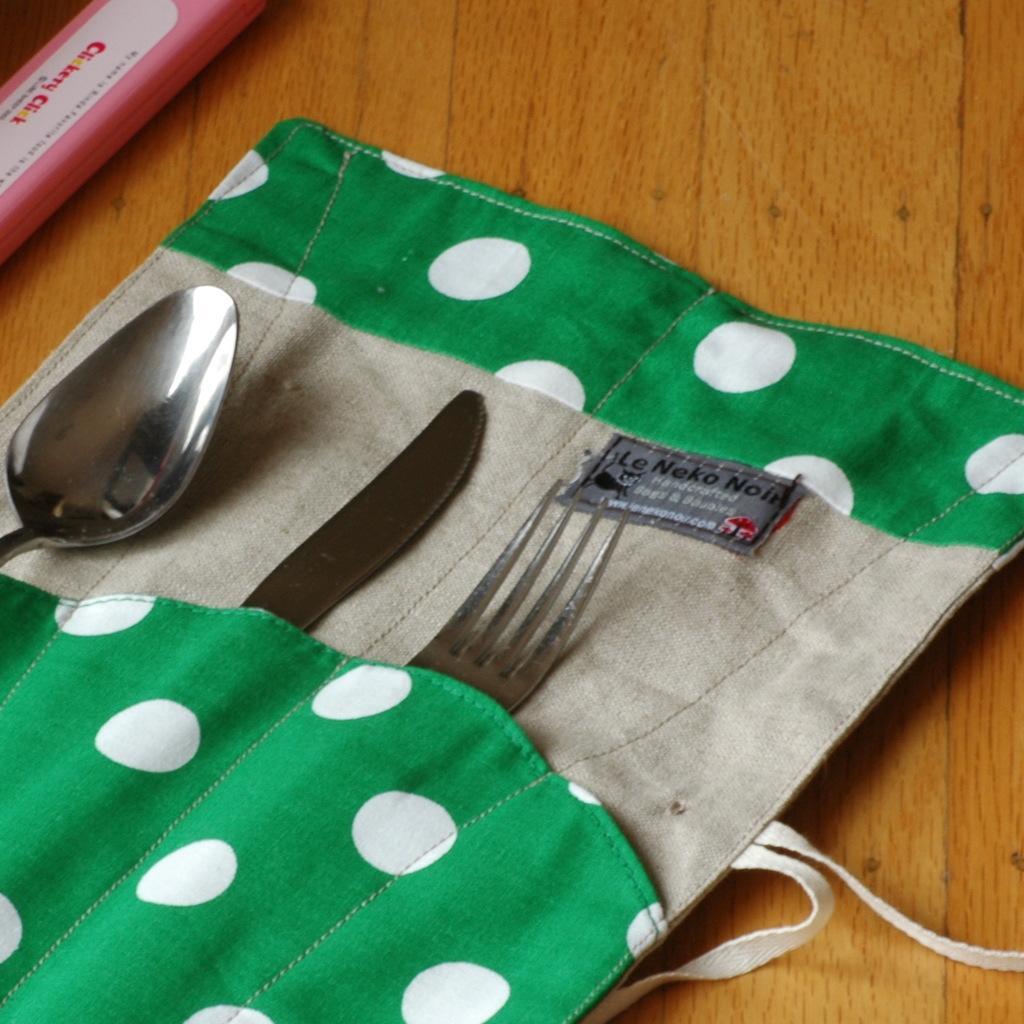How would you summarize this image in a sentence or two? In the image there is a table. On table we can see a cloth,fork,knife,spoon. 